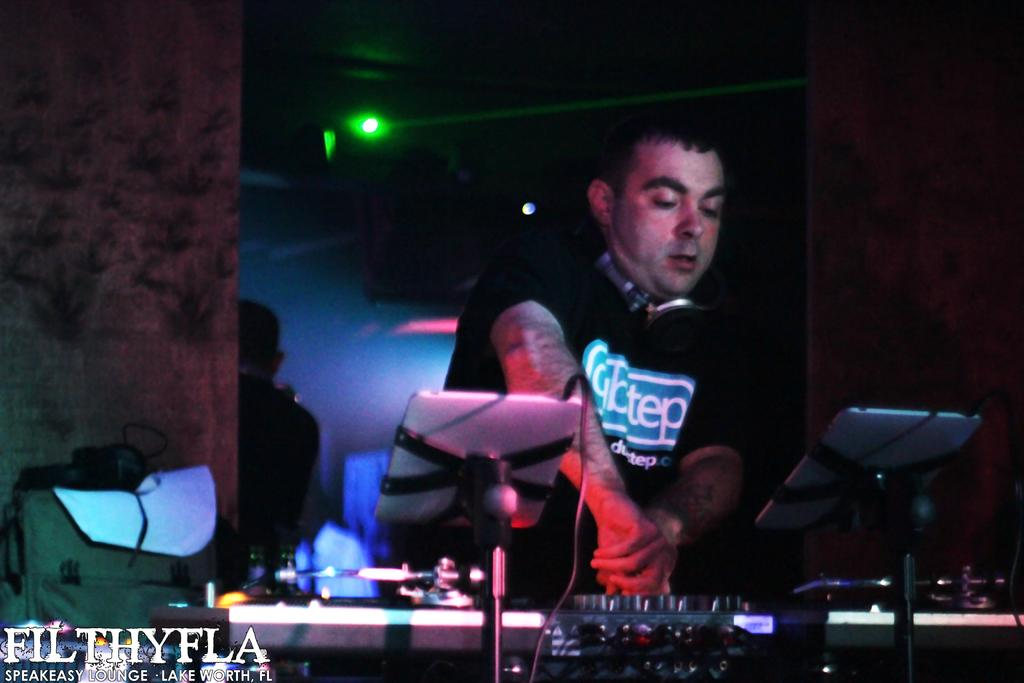What is the man in the image doing? The man is operating a music mixer. What is the man wearing that is related to his activity? The man is wearing a headset. What can be seen in the background of the image? There is a wall and a mirror in the background of the image. What color is the orange that the man is holding in the image? There is no orange present in the image; the man is operating a music mixer and wearing a headset. 